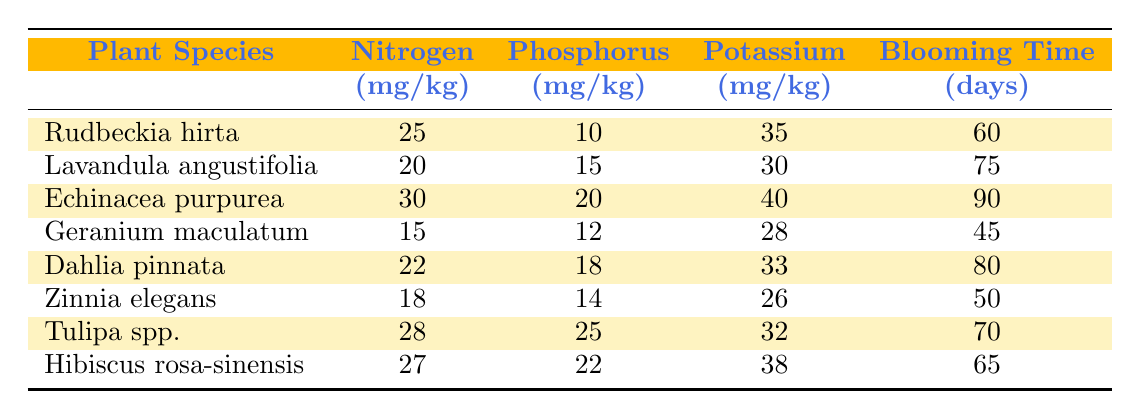What is the blooming time for Hibiscus rosa-sinensis? The table shows that for Hibiscus rosa-sinensis, the blooming time is listed in the corresponding row under the "Blooming Time" column, which indicates 65 days.
Answer: 65 days Which plant species has the highest Nitrogen level? By comparing the values listed under the "Nitrogen" column, Echinacea purpurea has the highest Nitrogen level at 30 mg/kg.
Answer: Echinacea purpurea What is the average Blooming Time for the plants with a Potassium level greater than 30 mg/kg? First, identify the plants with Potassium levels over 30 mg/kg: Rudbeckia hirta (35), Echinacea purpurea (40), Dahlia pinnata (33), Hibiscus rosa-sinensis (38). The Blooming Times for these plants are 60, 90, 80, and 65 days, summing them gives 60 + 90 + 80 + 65 = 295. Then divide by the number of plants (4) to find the average: 295/4 = 73.75.
Answer: 73.75 days Is there a correlation between higher Potassium levels and shorter Blooming Times in these plants? To analyze, look for Potassium levels and their corresponding Blooming Times. Zinnia elegans has a low Potassium level (26) and a shorter Blooming Time (50), while Echinacea purpurea has a high Potassium level (40) and a longer Blooming Time (90). The correlation is not consistent, indicating that higher Potassium does not guarantee shorter Blooming Times.
Answer: No How much more Phosphorus does Tulipa spp. have than Geranium maculatum? Tulipa spp. has 25 mg/kg of Phosphorus, while Geranium maculatum has 12 mg/kg. To find the difference, subtract the two: 25 - 12 = 13 mg/kg.
Answer: 13 mg/kg 